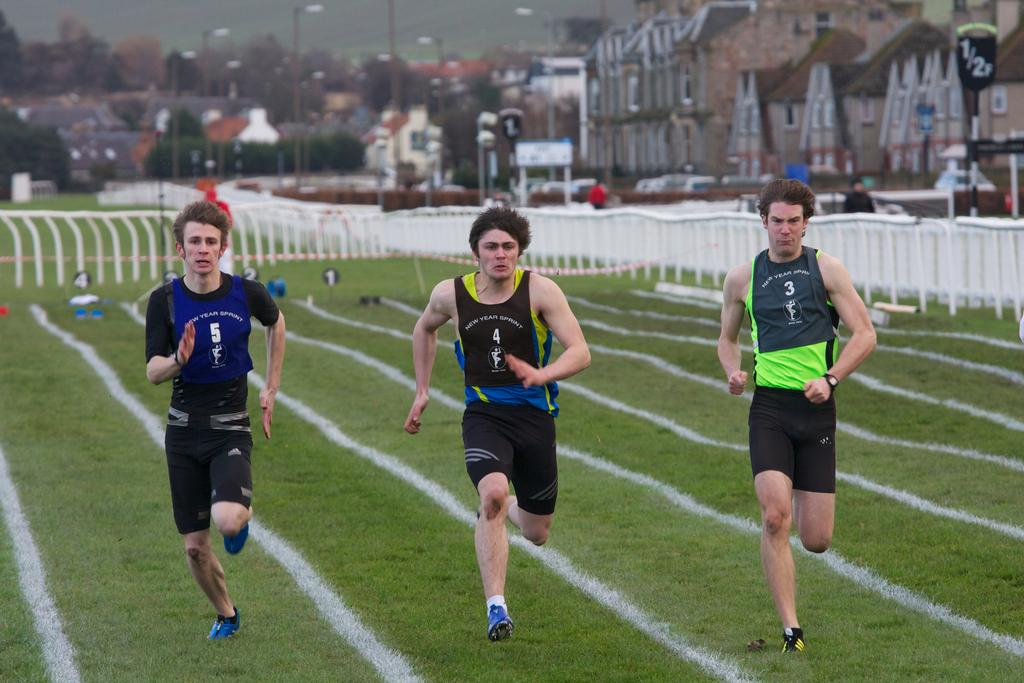Provide a one-sentence caption for the provided image. Three men are running a race and the jersey of the man in the center is numbered 4. 